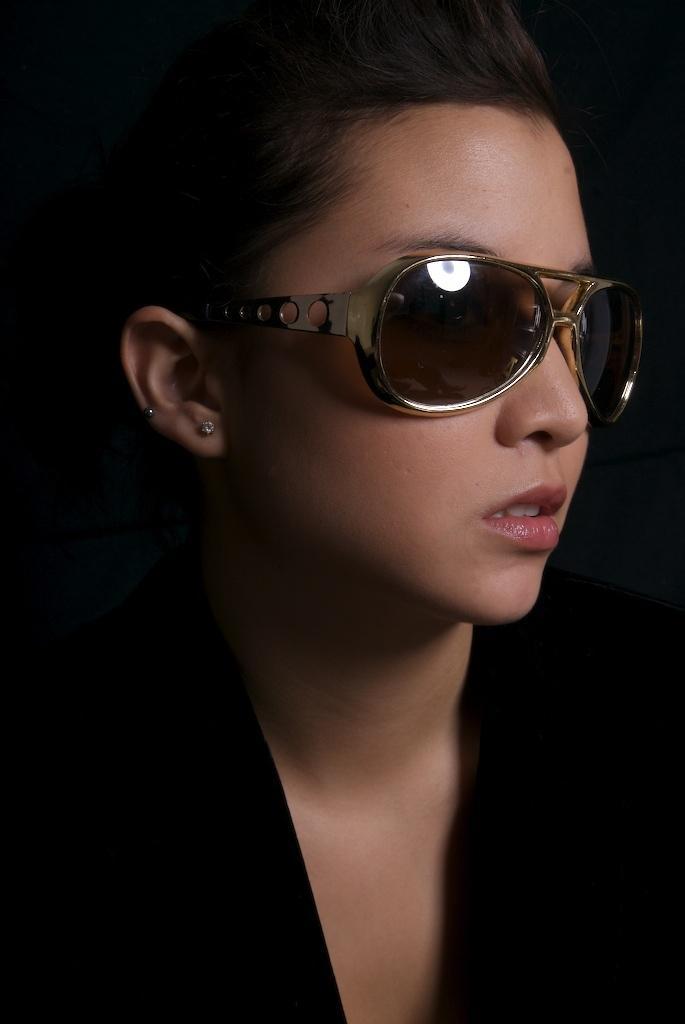Describe this image in one or two sentences. In the image we can see a woman wearing clothes, goggles and earring studs. 